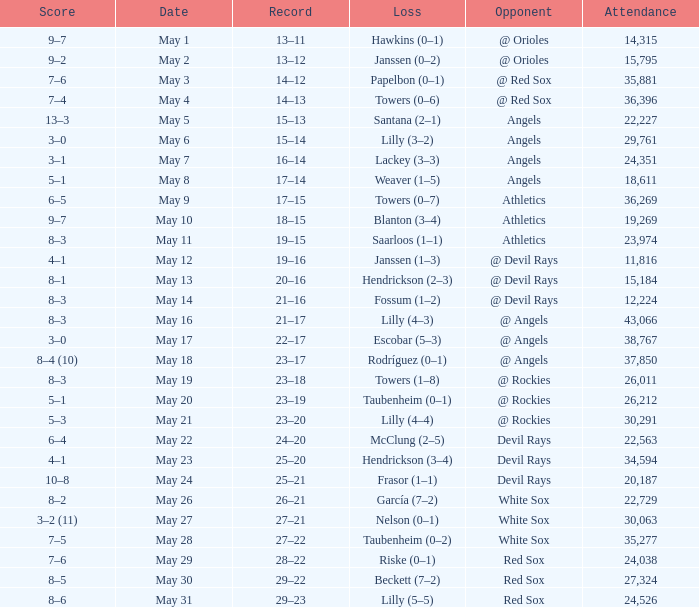What was the average attendance for games with a loss of papelbon (0–1)? 35881.0. 